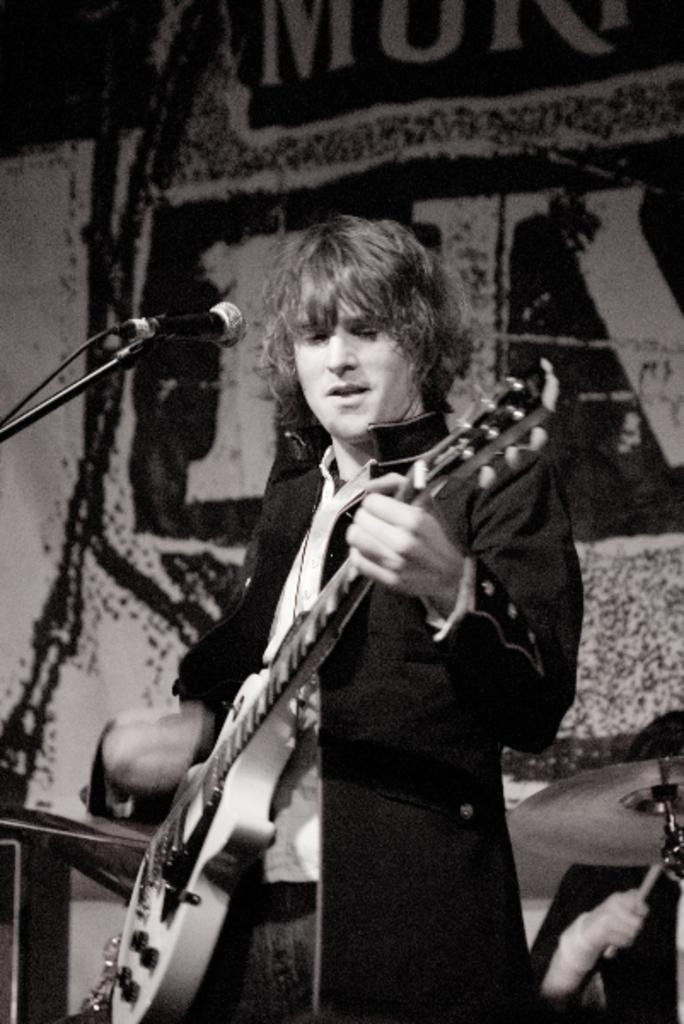What is the person in the image doing? The person is playing a guitar and singing. What object is the person using to amplify their voice? The person is in front of a microphone. What can be seen in the background of the image? There is a poster in the background of the image. What is written on the poster? The poster has the name "MURI" on it. How many donkeys are visible in the image? There are no donkeys present in the image. What type of drawer is being used by the person to store their guitar picks? There is no mention of a drawer in the image, and the person is not shown using one to store guitar picks. 